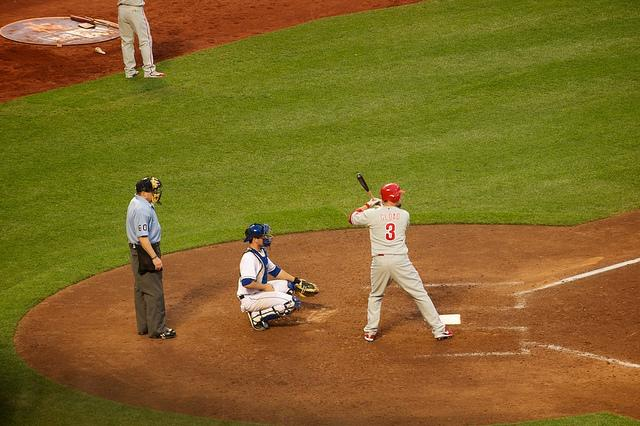Why is the batter wearing gloves? Please explain your reasoning. grip. This is so the bat doesn't slip out of his hands 